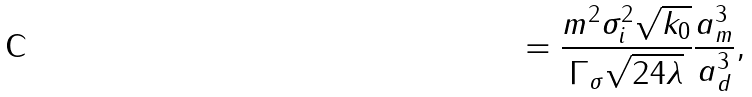Convert formula to latex. <formula><loc_0><loc_0><loc_500><loc_500>= \frac { m ^ { 2 } \sigma _ { i } ^ { 2 } \sqrt { k _ { 0 } } } { \Gamma _ { \sigma } \sqrt { 2 4 \lambda } } \frac { a _ { m } ^ { 3 } } { a _ { d } ^ { 3 } } ,</formula> 